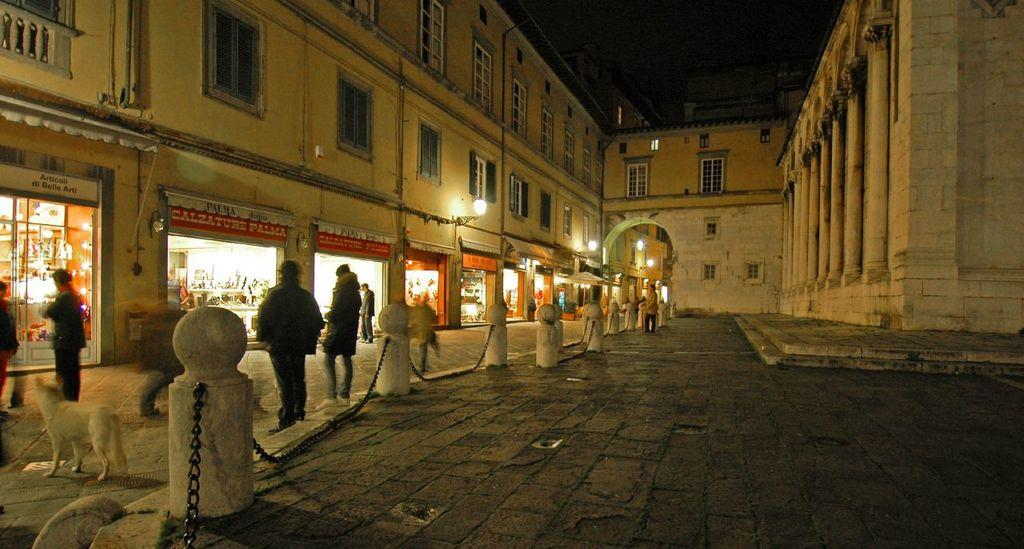<image>
Offer a succinct explanation of the picture presented. A sign over a store has the store name Palma on it. 